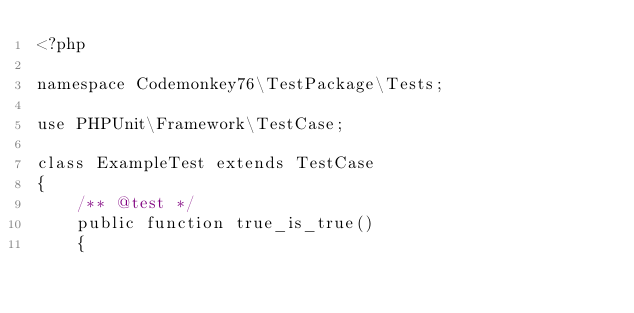Convert code to text. <code><loc_0><loc_0><loc_500><loc_500><_PHP_><?php

namespace Codemonkey76\TestPackage\Tests;

use PHPUnit\Framework\TestCase;

class ExampleTest extends TestCase
{
    /** @test */
    public function true_is_true()
    {</code> 